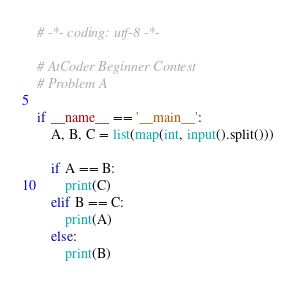Convert code to text. <code><loc_0><loc_0><loc_500><loc_500><_Python_># -*- coding: utf-8 -*-

# AtCoder Beginner Contest
# Problem A

if __name__ == '__main__':
    A, B, C = list(map(int, input().split()))

    if A == B:
        print(C)
    elif B == C:
        print(A)
    else:
        print(B)
</code> 